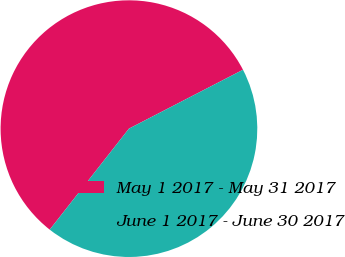<chart> <loc_0><loc_0><loc_500><loc_500><pie_chart><fcel>May 1 2017 - May 31 2017<fcel>June 1 2017 - June 30 2017<nl><fcel>56.83%<fcel>43.17%<nl></chart> 